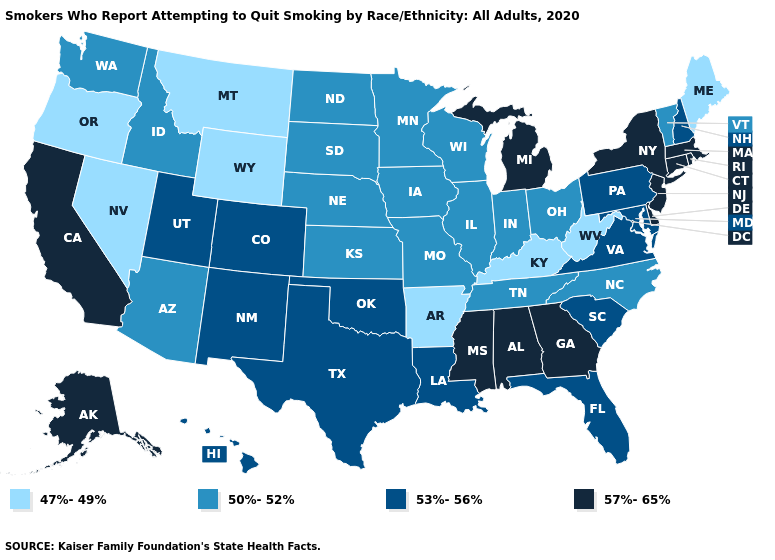Name the states that have a value in the range 57%-65%?
Write a very short answer. Alabama, Alaska, California, Connecticut, Delaware, Georgia, Massachusetts, Michigan, Mississippi, New Jersey, New York, Rhode Island. What is the value of Alabama?
Give a very brief answer. 57%-65%. What is the highest value in the West ?
Quick response, please. 57%-65%. Does the map have missing data?
Answer briefly. No. What is the highest value in states that border Illinois?
Quick response, please. 50%-52%. Does Arizona have a higher value than West Virginia?
Answer briefly. Yes. Does the first symbol in the legend represent the smallest category?
Quick response, please. Yes. Which states have the lowest value in the USA?
Concise answer only. Arkansas, Kentucky, Maine, Montana, Nevada, Oregon, West Virginia, Wyoming. What is the highest value in the USA?
Quick response, please. 57%-65%. Which states have the lowest value in the West?
Keep it brief. Montana, Nevada, Oregon, Wyoming. Which states hav the highest value in the Northeast?
Write a very short answer. Connecticut, Massachusetts, New Jersey, New York, Rhode Island. Does Wyoming have the lowest value in the USA?
Give a very brief answer. Yes. Does Oklahoma have the lowest value in the USA?
Answer briefly. No. What is the value of Oregon?
Concise answer only. 47%-49%. 